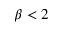<formula> <loc_0><loc_0><loc_500><loc_500>\beta < 2</formula> 